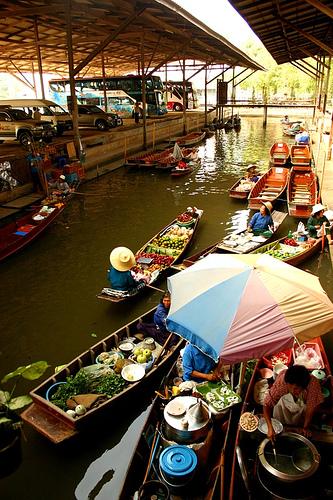Are the people floating?
Quick response, please. Yes. How many busses are shown in this picture?
Answer briefly. 2. What colors are the umbrella?
Quick response, please. Blue, red, yellow. 